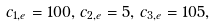<formula> <loc_0><loc_0><loc_500><loc_500>c _ { 1 , e } = 1 0 0 , \, c _ { 2 , e } = 5 , \, c _ { 3 , e } = 1 0 5 ,</formula> 